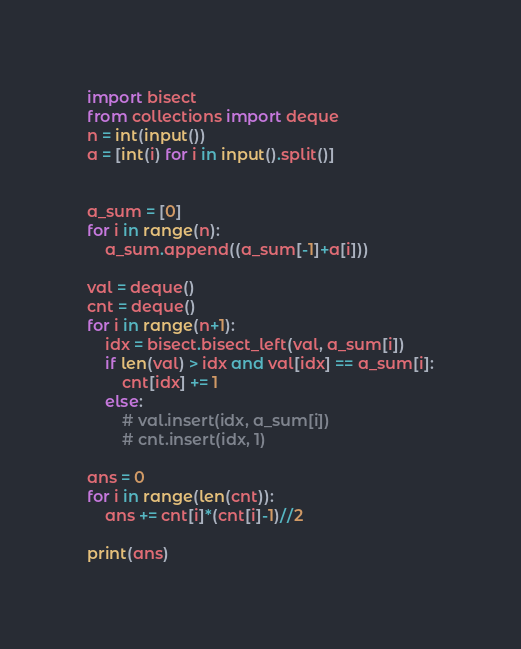Convert code to text. <code><loc_0><loc_0><loc_500><loc_500><_Python_>import bisect
from collections import deque
n = int(input())
a = [int(i) for i in input().split()]


a_sum = [0]
for i in range(n):
    a_sum.append((a_sum[-1]+a[i]))

val = deque()
cnt = deque()
for i in range(n+1):
    idx = bisect.bisect_left(val, a_sum[i])
    if len(val) > idx and val[idx] == a_sum[i]:
        cnt[idx] += 1
    else:
        # val.insert(idx, a_sum[i])
        # cnt.insert(idx, 1)

ans = 0
for i in range(len(cnt)):
    ans += cnt[i]*(cnt[i]-1)//2

print(ans)</code> 